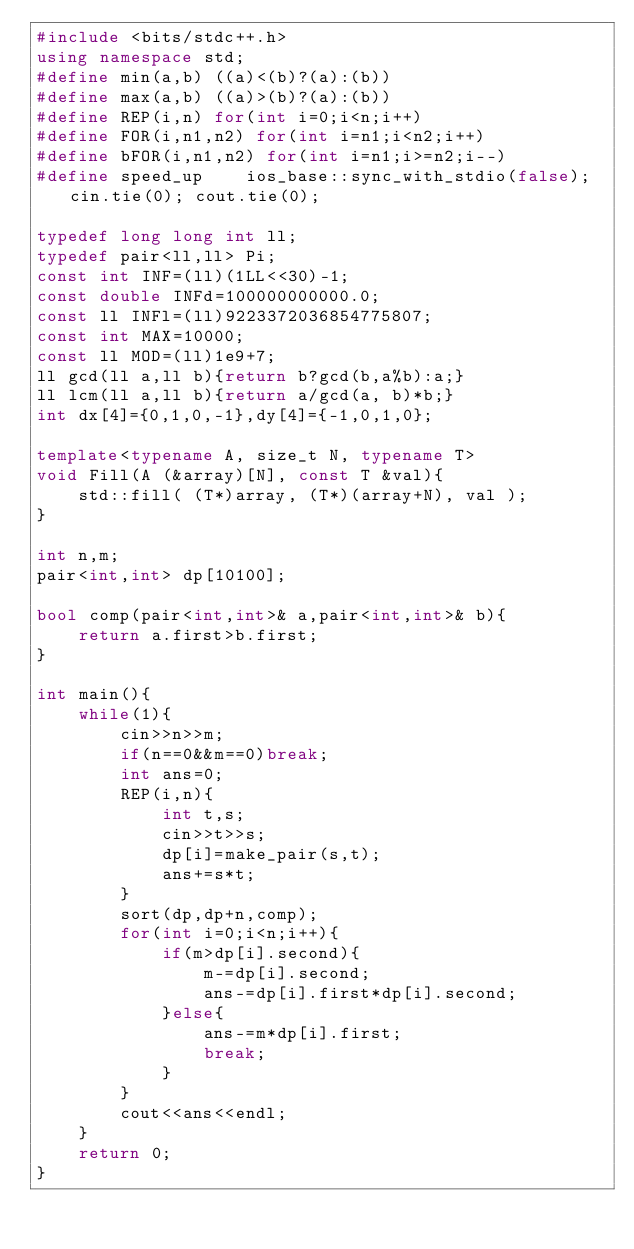Convert code to text. <code><loc_0><loc_0><loc_500><loc_500><_C++_>#include <bits/stdc++.h>
using namespace std;
#define min(a,b) ((a)<(b)?(a):(b))
#define max(a,b) ((a)>(b)?(a):(b))
#define REP(i,n) for(int i=0;i<n;i++)
#define FOR(i,n1,n2) for(int i=n1;i<n2;i++)
#define bFOR(i,n1,n2) for(int i=n1;i>=n2;i--)
#define speed_up    ios_base::sync_with_stdio(false); cin.tie(0); cout.tie(0);

typedef long long int ll;
typedef pair<ll,ll> Pi;
const int INF=(ll)(1LL<<30)-1;
const double INFd=100000000000.0;
const ll INFl=(ll)9223372036854775807;
const int MAX=10000;
const ll MOD=(ll)1e9+7;
ll gcd(ll a,ll b){return b?gcd(b,a%b):a;}
ll lcm(ll a,ll b){return a/gcd(a, b)*b;}
int dx[4]={0,1,0,-1},dy[4]={-1,0,1,0};

template<typename A, size_t N, typename T>
void Fill(A (&array)[N], const T &val){
    std::fill( (T*)array, (T*)(array+N), val );
}

int n,m;
pair<int,int> dp[10100];

bool comp(pair<int,int>& a,pair<int,int>& b){
	return a.first>b.first;
}

int main(){
	while(1){
		cin>>n>>m;
		if(n==0&&m==0)break;
		int ans=0;
		REP(i,n){
			int t,s;
			cin>>t>>s;
			dp[i]=make_pair(s,t);
			ans+=s*t;
		}
		sort(dp,dp+n,comp);
		for(int i=0;i<n;i++){
			if(m>dp[i].second){
				m-=dp[i].second;
				ans-=dp[i].first*dp[i].second;
			}else{
				ans-=m*dp[i].first;
				break;
			}
		}
		cout<<ans<<endl;
	}
	return 0;
}
</code> 